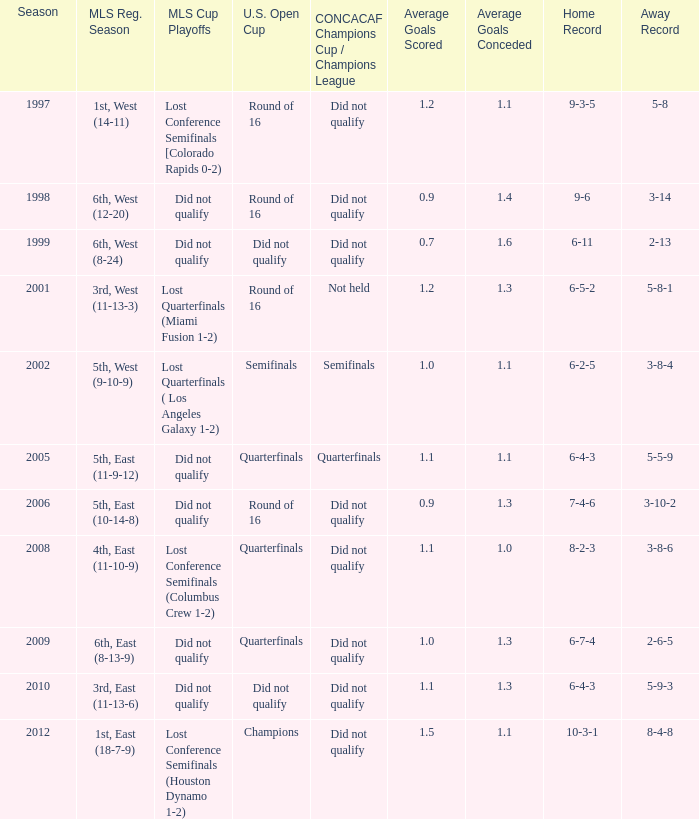When was the first season? 1997.0. 